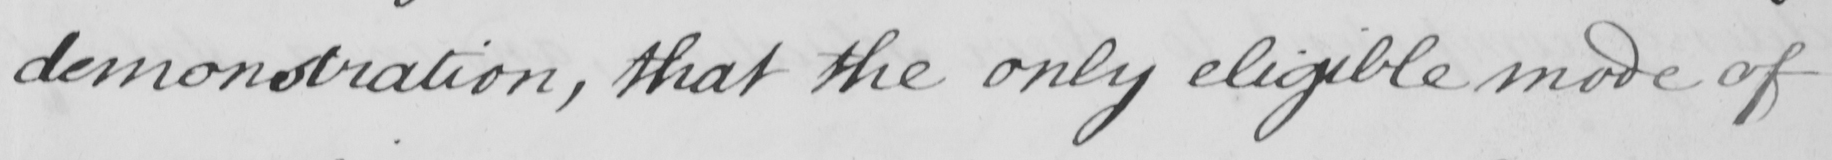Transcribe the text shown in this historical manuscript line. demonstration , that the only eligible mode of 